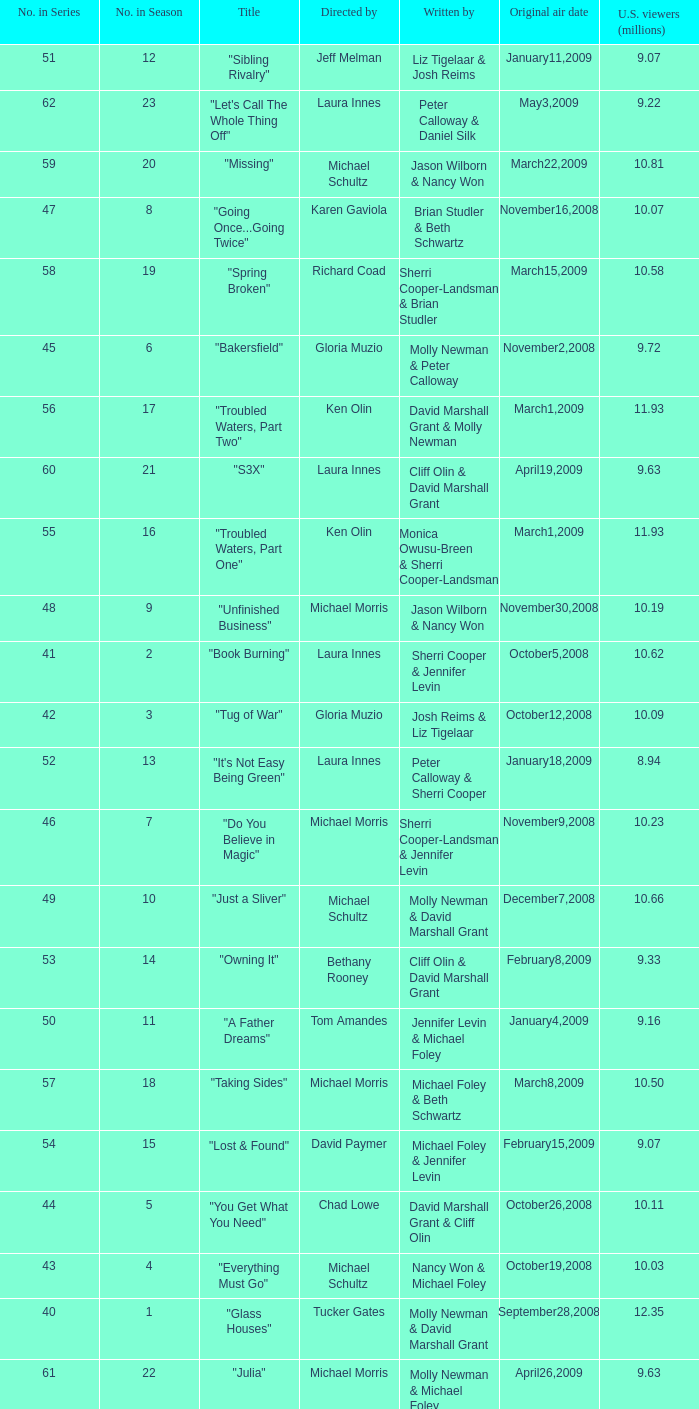When did the episode viewed by 10.50 millions of people in the US run for the first time? March8,2009. 